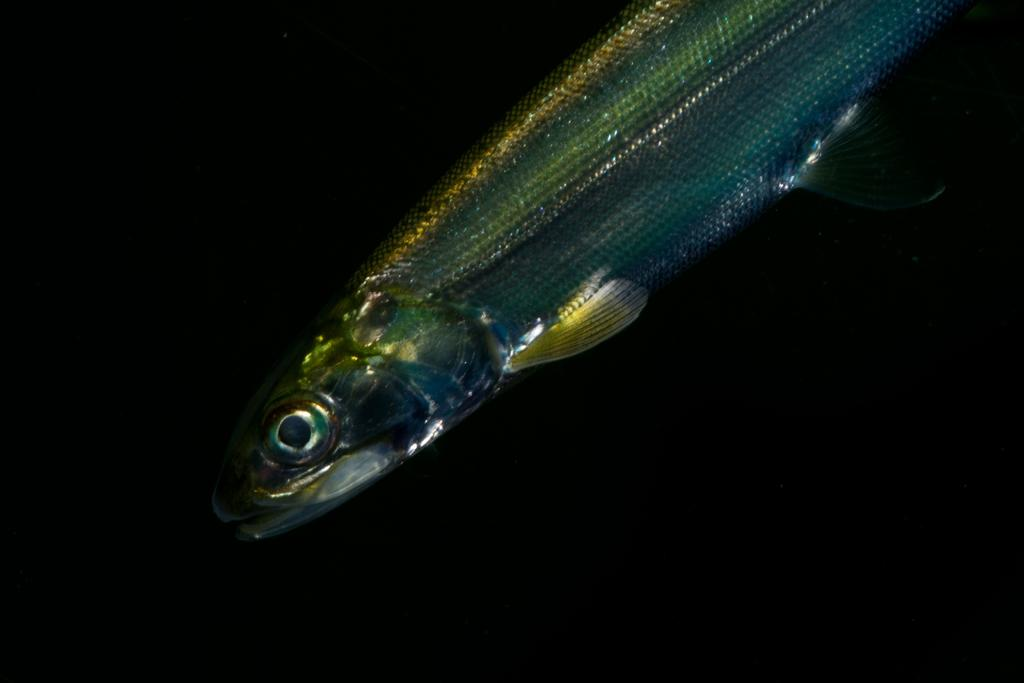What is the main subject of the image? There is a fish in the center of the image. What color is the background of the image? The background of the image is black. What religion does the fish in the image practice? Fish do not practice religion, as they are animals and do not have the cognitive ability to understand or participate in religious practices. 